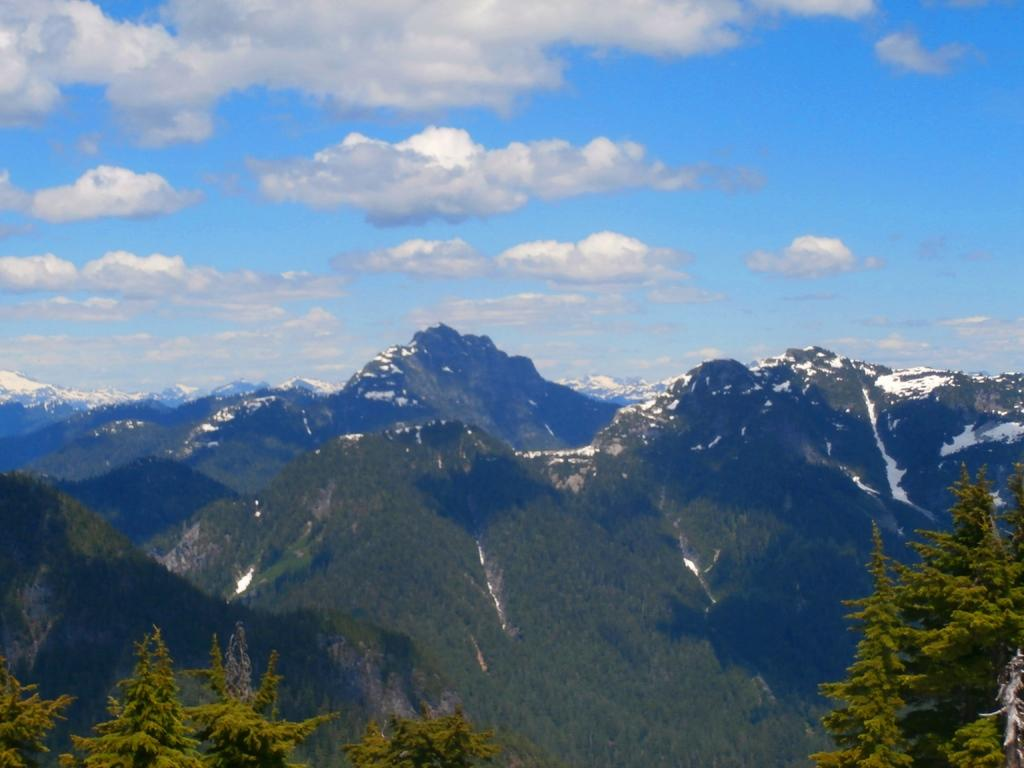What type of vegetation can be seen in the image? There are trees in the image. What type of landscape feature is present in the image? There are hills in the image. What is visible in the sky in the image? The sky is visible in the image. What is the weather like in the image? The presence of snow on the hills suggests that it is cold and possibly winter. What type of verse can be seen written on the flag in the image? There is no flag present in the image, so it is not possible to determine if there is any verse written on it. 